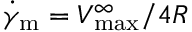<formula> <loc_0><loc_0><loc_500><loc_500>\dot { \gamma } _ { m } = V _ { \max } ^ { \infty } / 4 R</formula> 